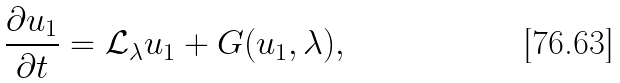<formula> <loc_0><loc_0><loc_500><loc_500>\frac { \partial u _ { 1 } } { \partial t } = { \mathcal { L } } _ { \lambda } u _ { 1 } + G ( u _ { 1 } , \lambda ) ,</formula> 